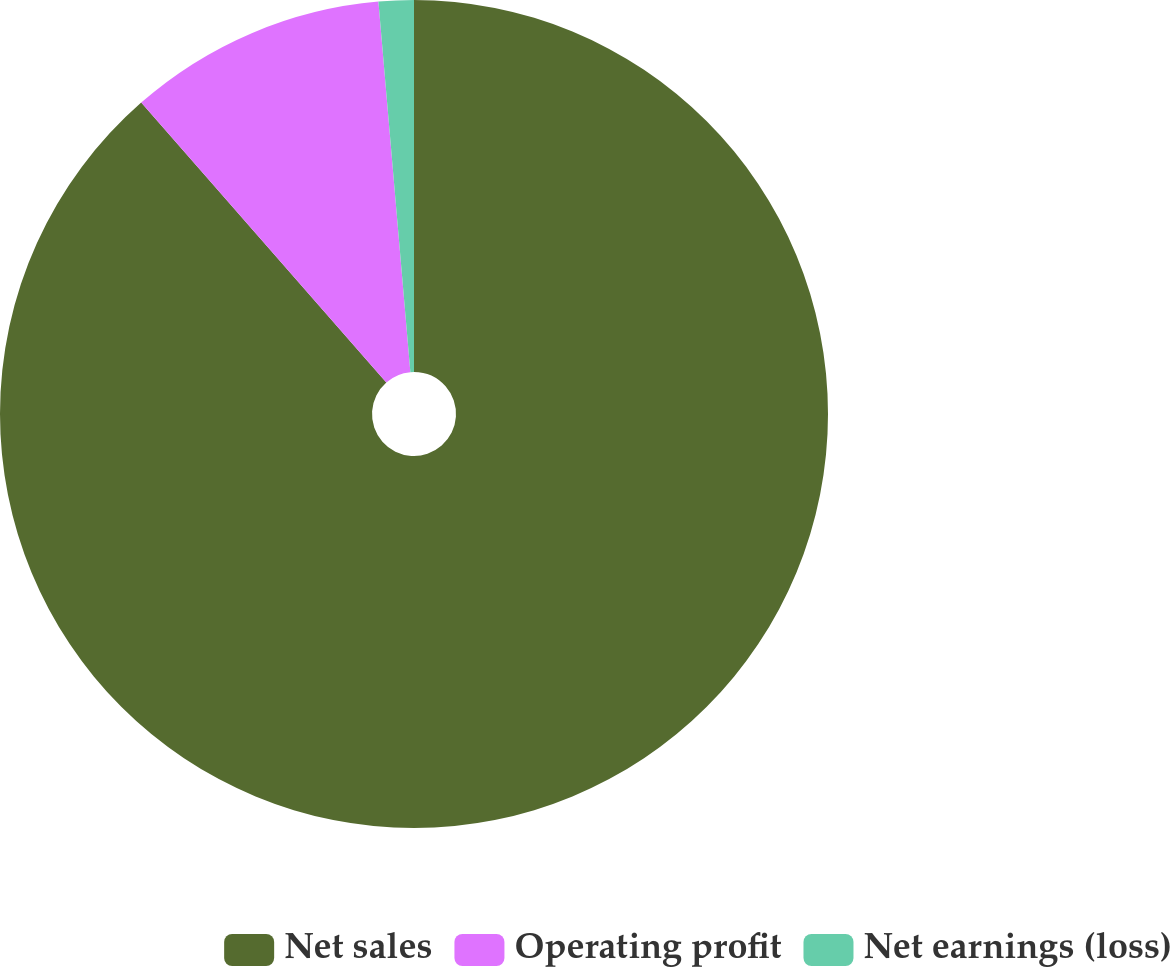Convert chart to OTSL. <chart><loc_0><loc_0><loc_500><loc_500><pie_chart><fcel>Net sales<fcel>Operating profit<fcel>Net earnings (loss)<nl><fcel>88.55%<fcel>10.08%<fcel>1.37%<nl></chart> 